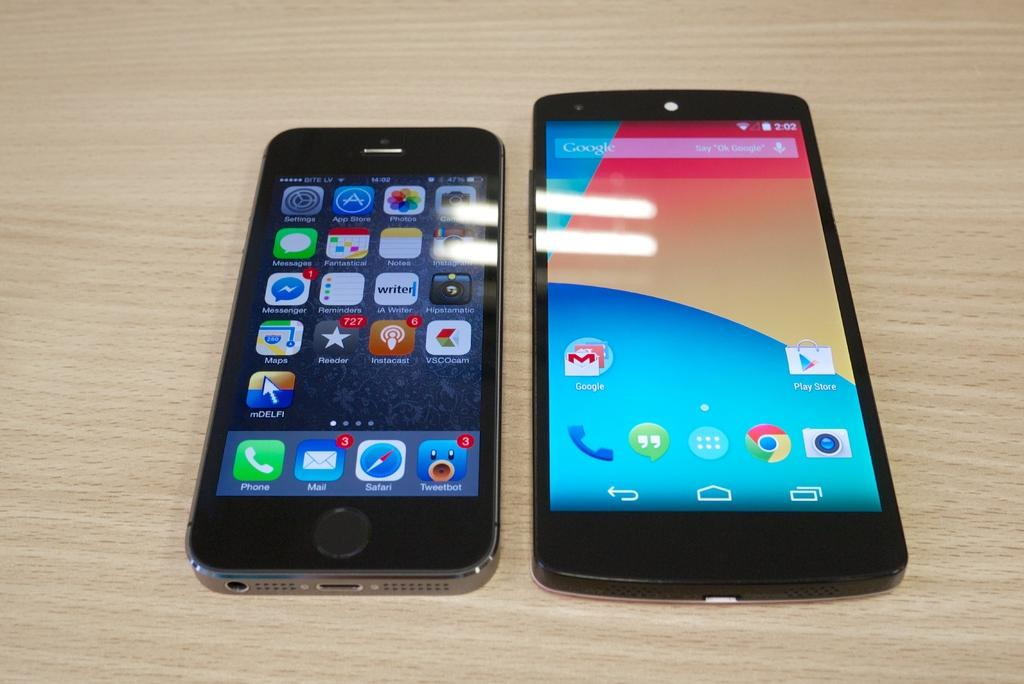<image>
Offer a succinct explanation of the picture presented. An Apple iPhone next to an unmarked Android phone with a Google Search Bar at the top of it. 